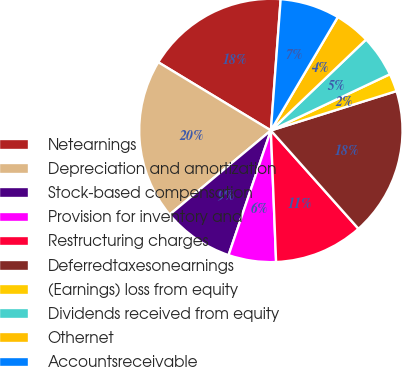<chart> <loc_0><loc_0><loc_500><loc_500><pie_chart><fcel>Netearnings<fcel>Depreciation and amortization<fcel>Stock-based compensation<fcel>Provision for inventory and<fcel>Restructuring charges<fcel>Deferredtaxesonearnings<fcel>(Earnings) loss from equity<fcel>Dividends received from equity<fcel>Othernet<fcel>Accountsreceivable<nl><fcel>17.52%<fcel>19.7%<fcel>8.76%<fcel>5.84%<fcel>10.95%<fcel>18.25%<fcel>2.19%<fcel>5.11%<fcel>4.38%<fcel>7.3%<nl></chart> 